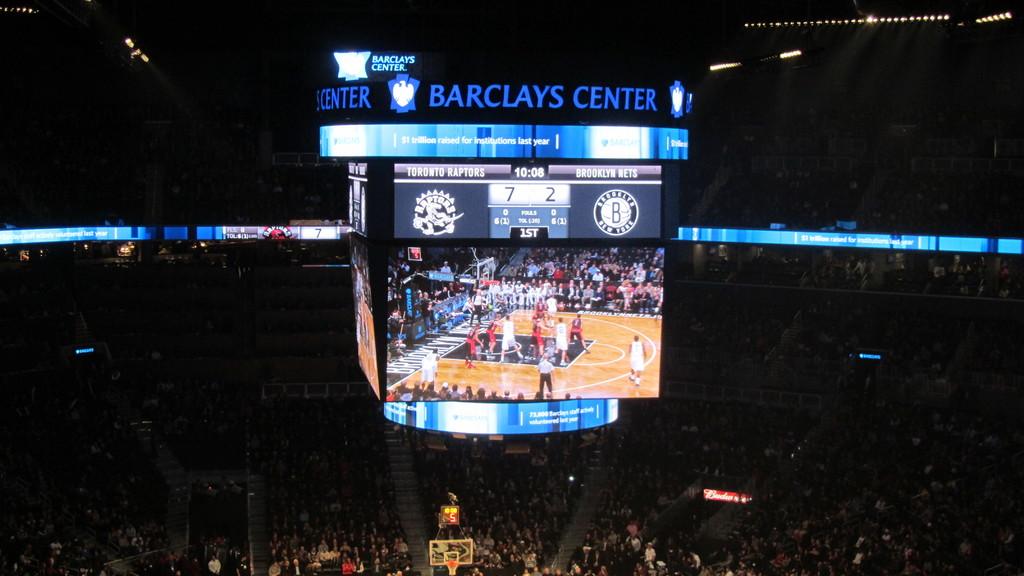Where is the barclay center?
Your response must be concise. Unanswerable. Where is this game taking place?
Make the answer very short. Barclays center. 